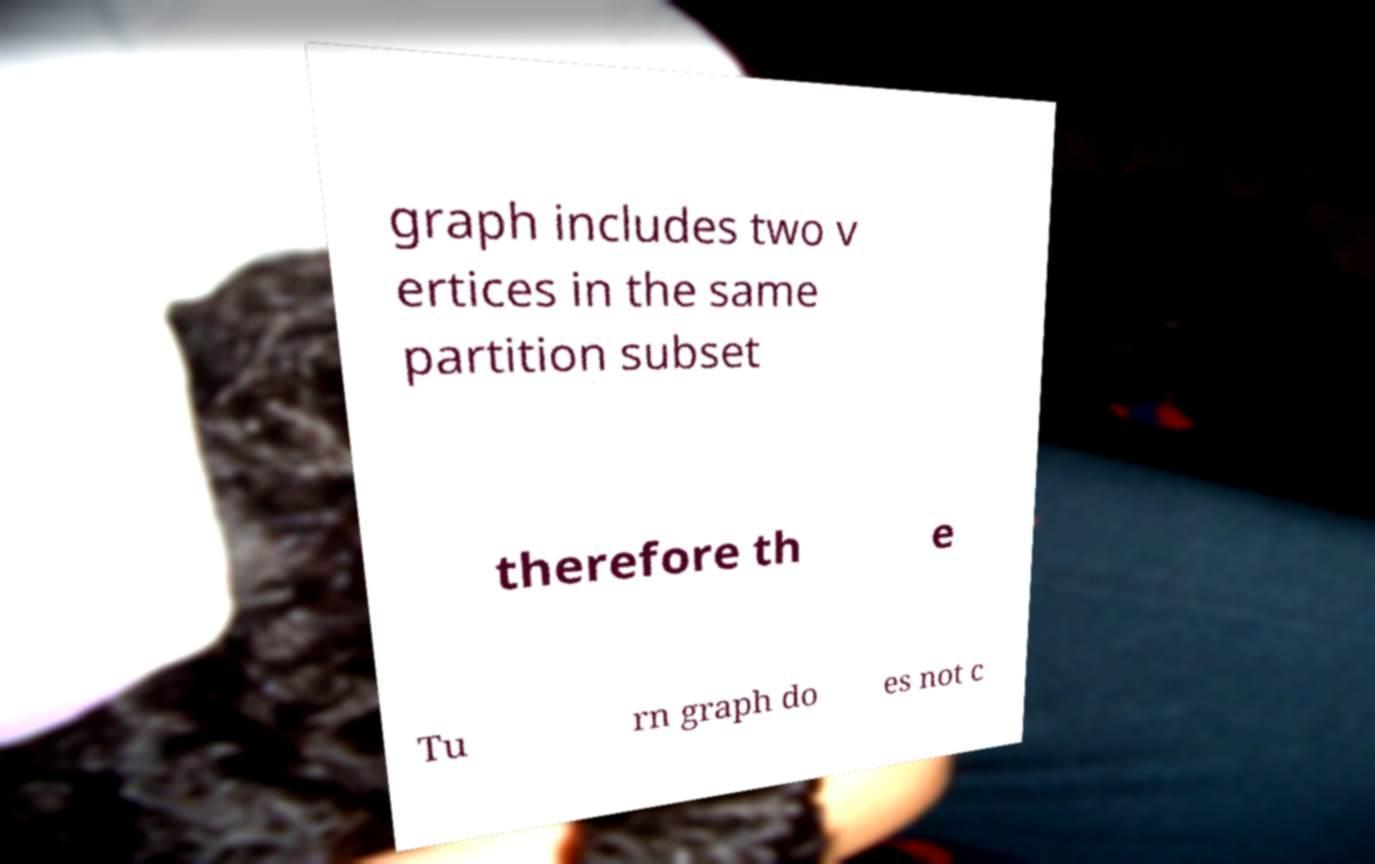For documentation purposes, I need the text within this image transcribed. Could you provide that? graph includes two v ertices in the same partition subset therefore th e Tu rn graph do es not c 